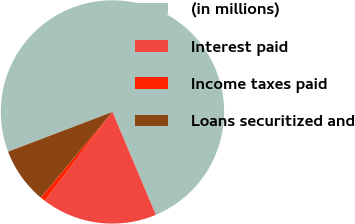<chart> <loc_0><loc_0><loc_500><loc_500><pie_chart><fcel>(in millions)<fcel>Interest paid<fcel>Income taxes paid<fcel>Loans securitized and<nl><fcel>74.44%<fcel>16.71%<fcel>0.74%<fcel>8.11%<nl></chart> 